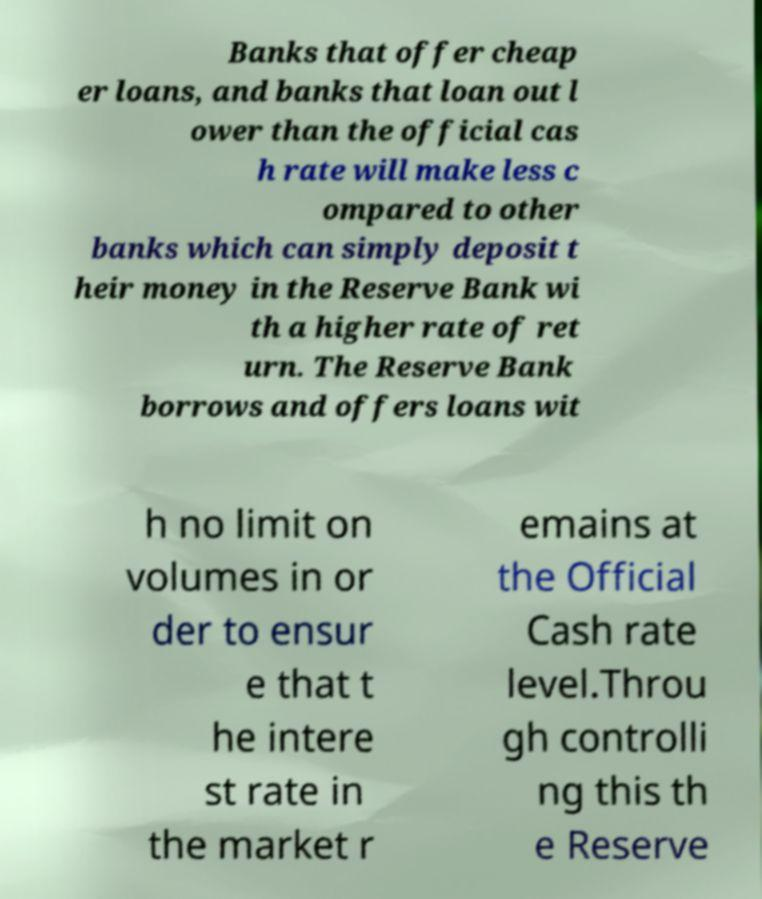Can you read and provide the text displayed in the image?This photo seems to have some interesting text. Can you extract and type it out for me? Banks that offer cheap er loans, and banks that loan out l ower than the official cas h rate will make less c ompared to other banks which can simply deposit t heir money in the Reserve Bank wi th a higher rate of ret urn. The Reserve Bank borrows and offers loans wit h no limit on volumes in or der to ensur e that t he intere st rate in the market r emains at the Official Cash rate level.Throu gh controlli ng this th e Reserve 